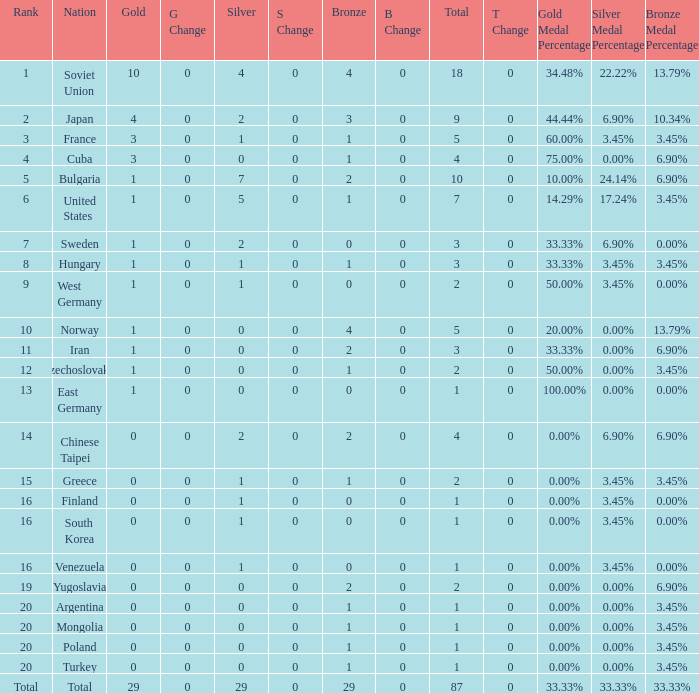Which rank has 1 silver medal and more than 1 gold medal? 3.0. 